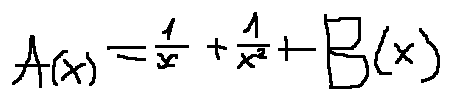<formula> <loc_0><loc_0><loc_500><loc_500>A ( x ) = \frac { 1 } { x } + \frac { 1 } { x ^ { 2 } } + B ( x )</formula> 